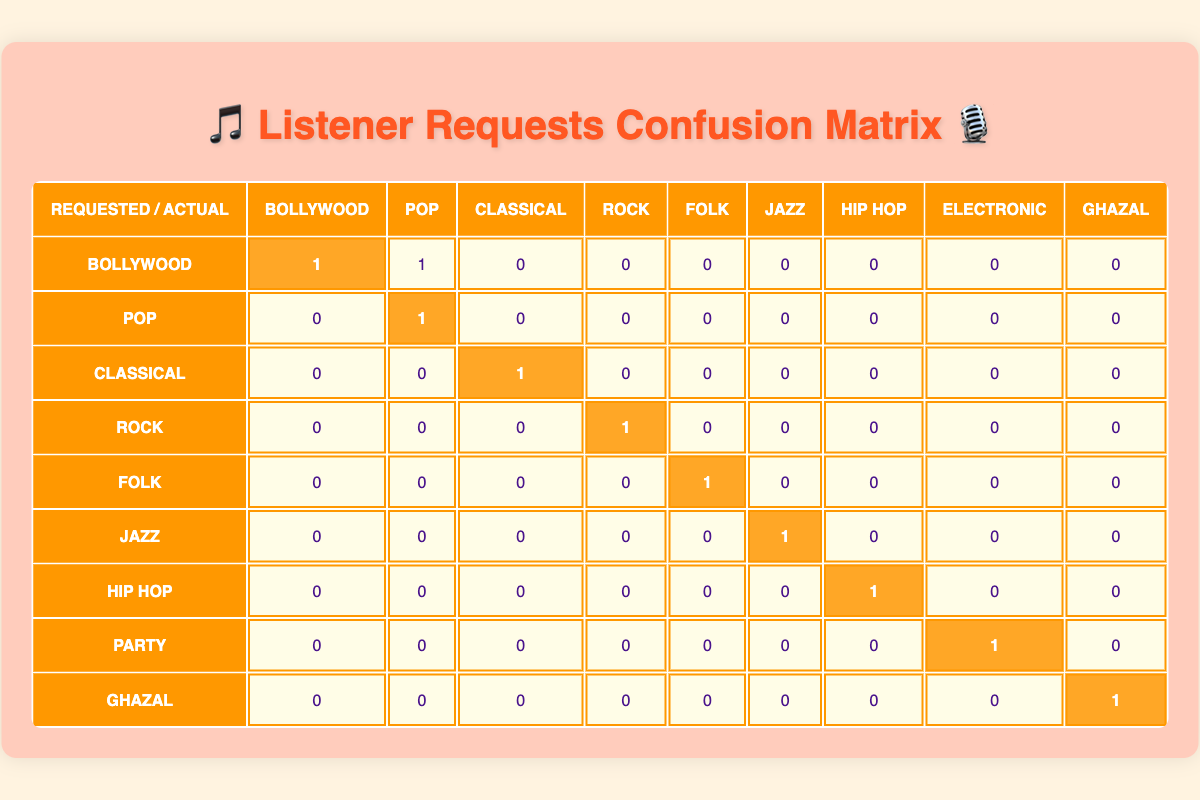What is the count of requests for the Bollywood genre? In the table, under the Bollywood row and Bollywood column, the highlighted cell shows the count, which is 1.
Answer: 1 How many requests were made for the Classical genre? Looking at the Classical row and Classical column, the highlighted cell indicates that there is 1 request for the Classical genre.
Answer: 1 Is there any request for the Rock genre that matched its actual genre? From the Rock row and Rock column, the highlighted cell shows that there is 1 matching request for the Rock genre.
Answer: Yes What is the total number of requests received for the Hindi language? To find this, I will sum the actual genre counts in the Hindi columns for Bollywood, Classical, Folk, and Ghazal, which shows a count of 1 for Bollywood, 0 for Classical, 1 for Folk, and 1 for Ghazal. So total = 1 + 0 + 1 + 1 = 3.
Answer: 3 Did any listeners request the Electronic genre and received that genre in return? Checking the Party row and Electronic column, the count there is shown as 1, which indicates that there was a request made for the Electronic genre that was fulfilled as such.
Answer: No What is the difference between the number of requests for English genres (Pop, Rock, Jazz, Hip Hop, and Electronic) that matched and those that did not match? From the table, the matched counts are 1 for Pop, 0 for Rock, 1 for Jazz, and 0 for Electronic, which sums to 2. For unmatched requests: Rock (1 unmatched), Party (1 unmatched), and Hip Hop (1 unmatched). Total unmatched = 1 + 1 + 1 = 3. Difference = 2 - 3 = -1.
Answer: -1 How many types of genres had both requests and actual fulfillment? The genres are Bollywood, Pop, Classical, Folk, Jazz, Hip Hop, and Ghazal. Each of these corresponds to successful requests, totaling 7 types that matched requests with actual genres successfully.
Answer: 7 Which has more requests: the Hip Hop genre or the Ghazal genre? The count for Hip Hop is 1 and for Ghazal is 1, thus they both have the same number of requests, leading to equal comparison between these two genres.
Answer: Equal Count the total number of requests that were fulfilled incorrectly (i.e., requested genre does not match actual genre). The incorrect matches could be seen in the Bollywood to Pop (1), Rock to Hindi (1), and Party to Electronic (1). Total = 1 + 1 + 1 = 3 requests that were fulfilled incorrectly.
Answer: 3 